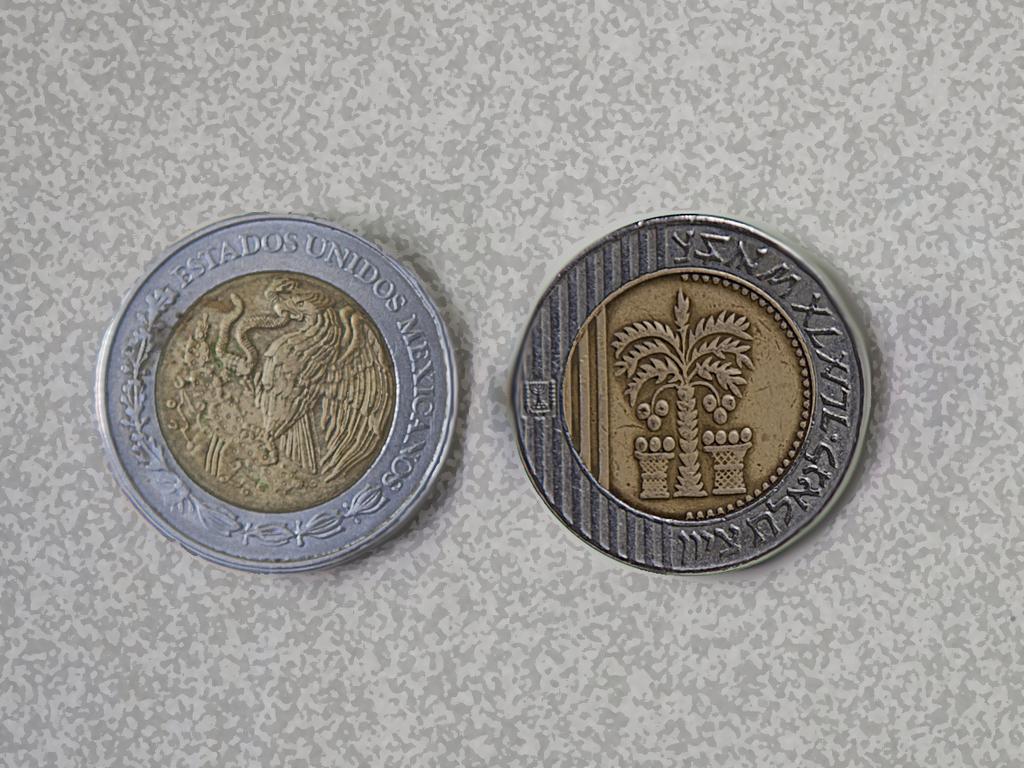What country is the currency from?
Provide a succinct answer. Mexico. 